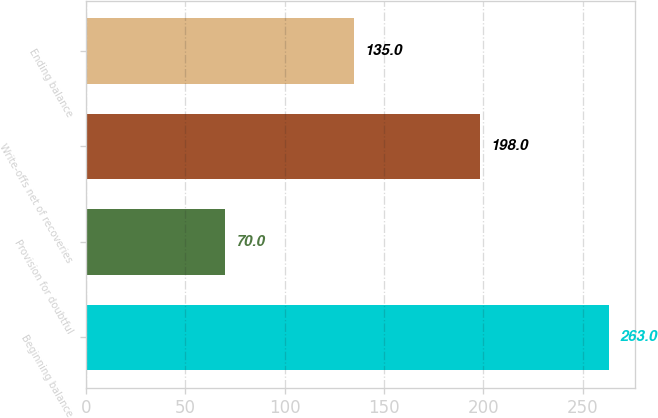<chart> <loc_0><loc_0><loc_500><loc_500><bar_chart><fcel>Beginning balance<fcel>Provision for doubtful<fcel>Write-offs net of recoveries<fcel>Ending balance<nl><fcel>263<fcel>70<fcel>198<fcel>135<nl></chart> 